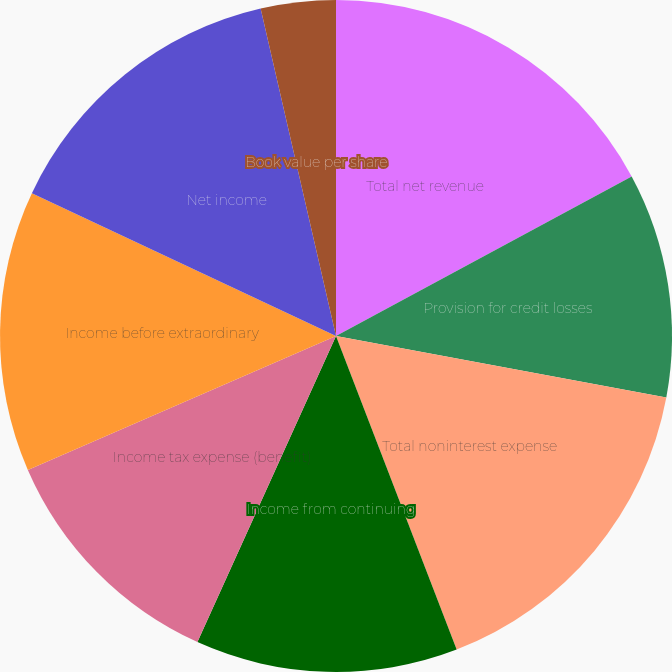Convert chart. <chart><loc_0><loc_0><loc_500><loc_500><pie_chart><fcel>Total net revenue<fcel>Provision for credit losses<fcel>Total noninterest expense<fcel>Income from continuing<fcel>Income tax expense (benefit)<fcel>Income before extraordinary<fcel>Net income<fcel>Cash dividends declared per<fcel>Book value per share<nl><fcel>17.12%<fcel>10.81%<fcel>16.22%<fcel>12.61%<fcel>11.71%<fcel>13.51%<fcel>14.41%<fcel>0.0%<fcel>3.6%<nl></chart> 